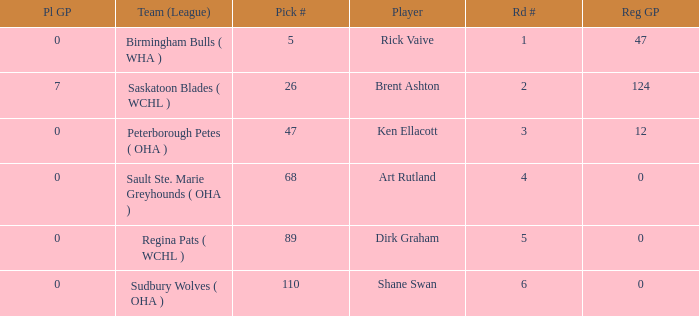How many reg GP for rick vaive in round 1? None. 